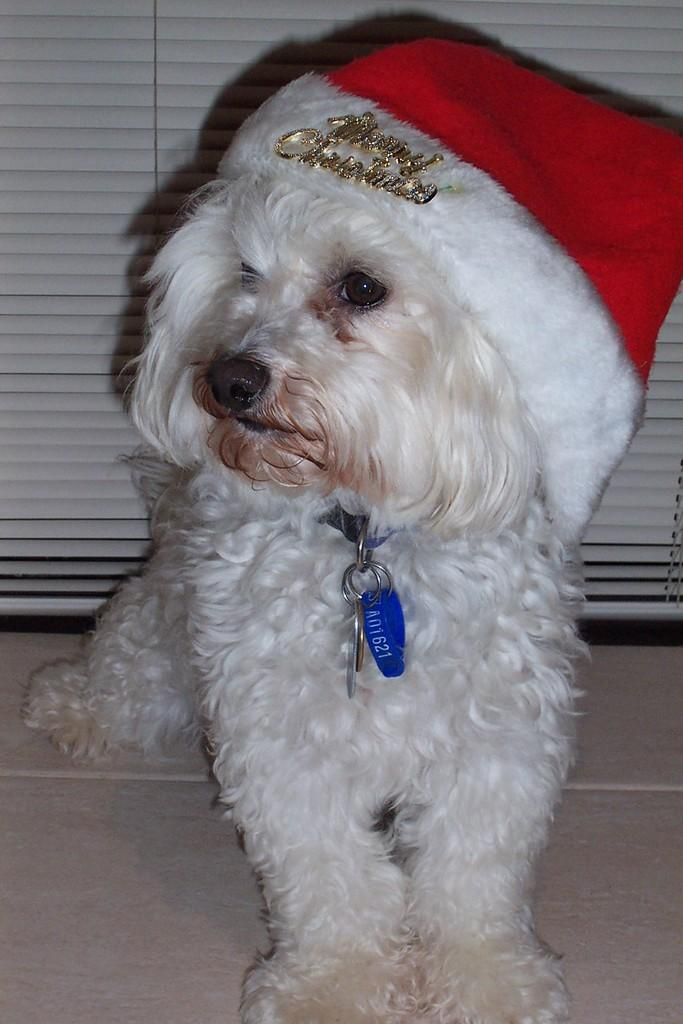What type of animal is in the image? There is a dog in the image. Where is the dog located? The dog is on the floor. What is on the dog's head? There is a cap on the dog's head. What is tied around the dog's neck? There is a belt tied to the dog's neck. What can be seen in the background of the image? There is a window visible in the background of the image. What request does the dog's sister make in the image? There is no mention of a sister or any request in the image. 